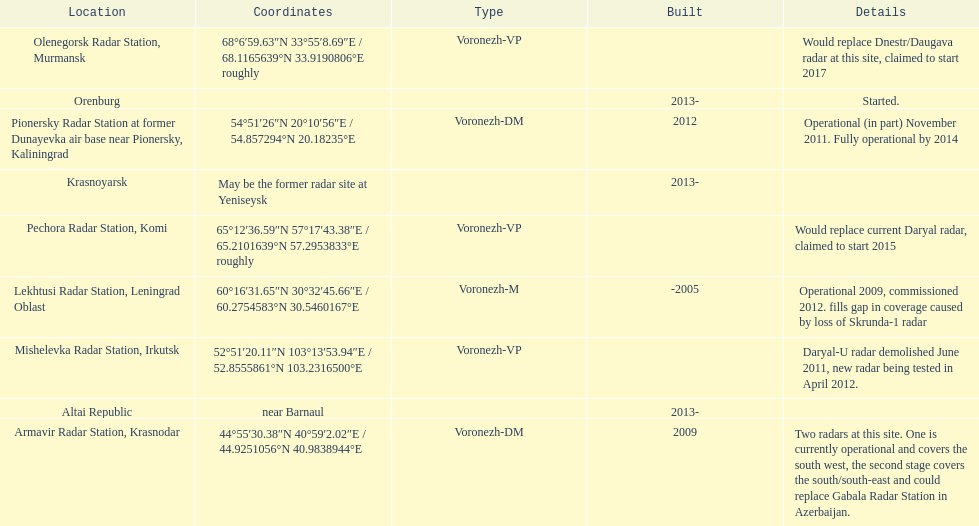How many voronezh radars are in kaliningrad or in krasnodar? 2. Parse the table in full. {'header': ['Location', 'Coordinates', 'Type', 'Built', 'Details'], 'rows': [['Olenegorsk Radar Station, Murmansk', '68°6′59.63″N 33°55′8.69″E\ufeff / \ufeff68.1165639°N 33.9190806°E roughly', 'Voronezh-VP', '', 'Would replace Dnestr/Daugava radar at this site, claimed to start 2017'], ['Orenburg', '', '', '2013-', 'Started.'], ['Pionersky Radar Station at former Dunayevka air base near Pionersky, Kaliningrad', '54°51′26″N 20°10′56″E\ufeff / \ufeff54.857294°N 20.18235°E', 'Voronezh-DM', '2012', 'Operational (in part) November 2011. Fully operational by 2014'], ['Krasnoyarsk', 'May be the former radar site at Yeniseysk', '', '2013-', ''], ['Pechora Radar Station, Komi', '65°12′36.59″N 57°17′43.38″E\ufeff / \ufeff65.2101639°N 57.2953833°E roughly', 'Voronezh-VP', '', 'Would replace current Daryal radar, claimed to start 2015'], ['Lekhtusi Radar Station, Leningrad Oblast', '60°16′31.65″N 30°32′45.66″E\ufeff / \ufeff60.2754583°N 30.5460167°E', 'Voronezh-M', '-2005', 'Operational 2009, commissioned 2012. fills gap in coverage caused by loss of Skrunda-1 radar'], ['Mishelevka Radar Station, Irkutsk', '52°51′20.11″N 103°13′53.94″E\ufeff / \ufeff52.8555861°N 103.2316500°E', 'Voronezh-VP', '', 'Daryal-U radar demolished June 2011, new radar being tested in April 2012.'], ['Altai Republic', 'near Barnaul', '', '2013-', ''], ['Armavir Radar Station, Krasnodar', '44°55′30.38″N 40°59′2.02″E\ufeff / \ufeff44.9251056°N 40.9838944°E', 'Voronezh-DM', '2009', 'Two radars at this site. One is currently operational and covers the south west, the second stage covers the south/south-east and could replace Gabala Radar Station in Azerbaijan.']]} 